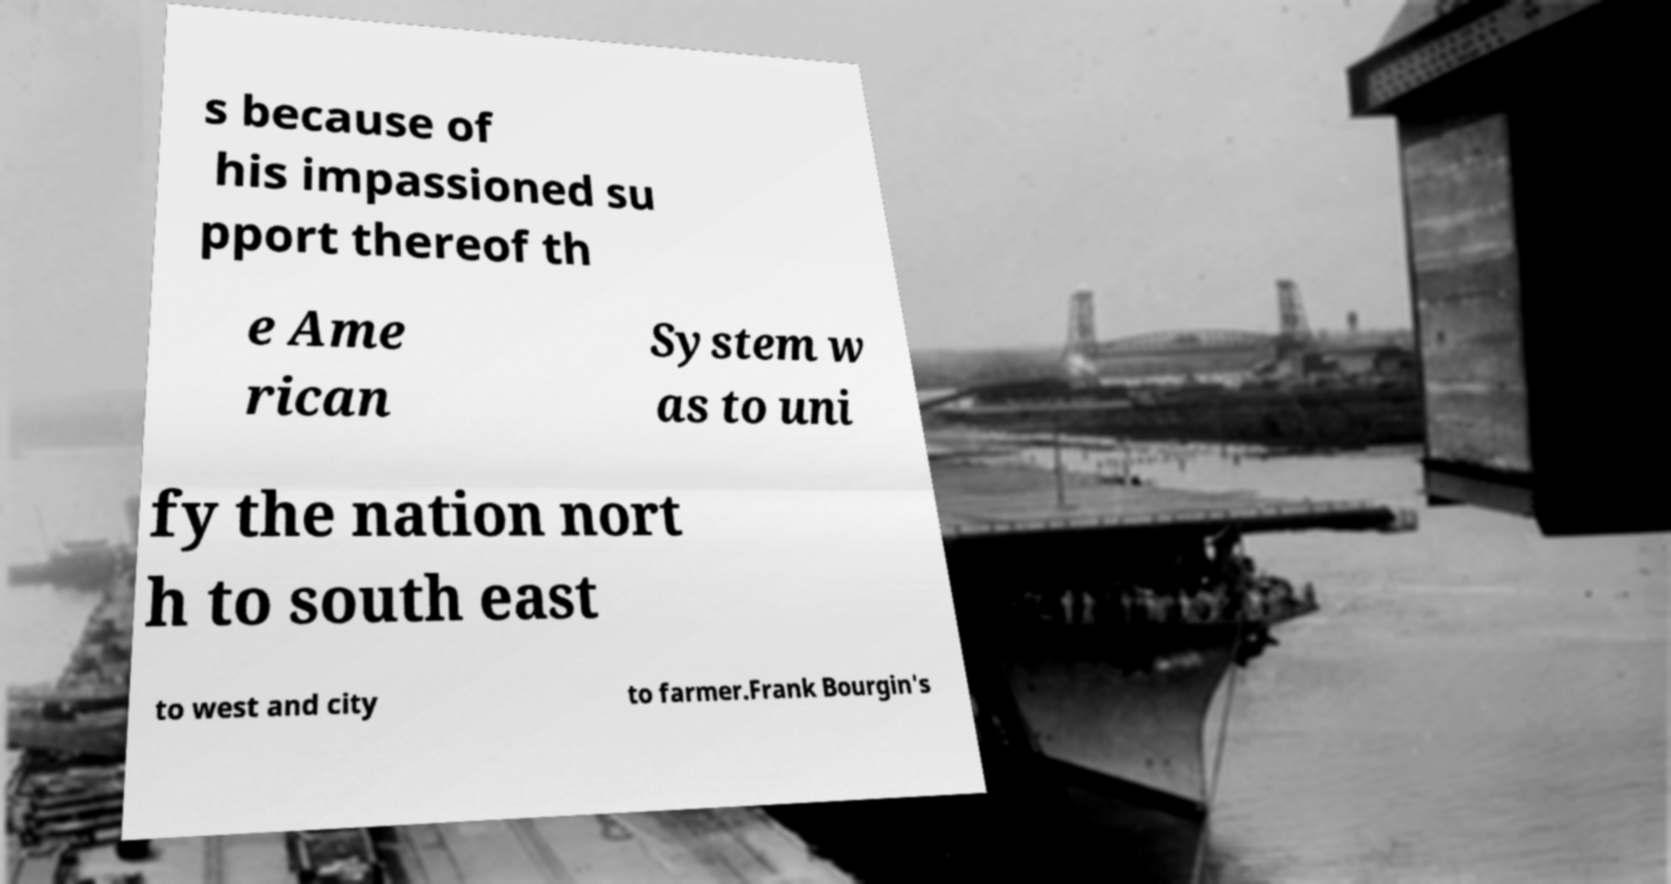Please identify and transcribe the text found in this image. s because of his impassioned su pport thereof th e Ame rican System w as to uni fy the nation nort h to south east to west and city to farmer.Frank Bourgin's 